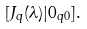<formula> <loc_0><loc_0><loc_500><loc_500>[ J _ { q } ( \lambda ) | 0 _ { q 0 } ] .</formula> 